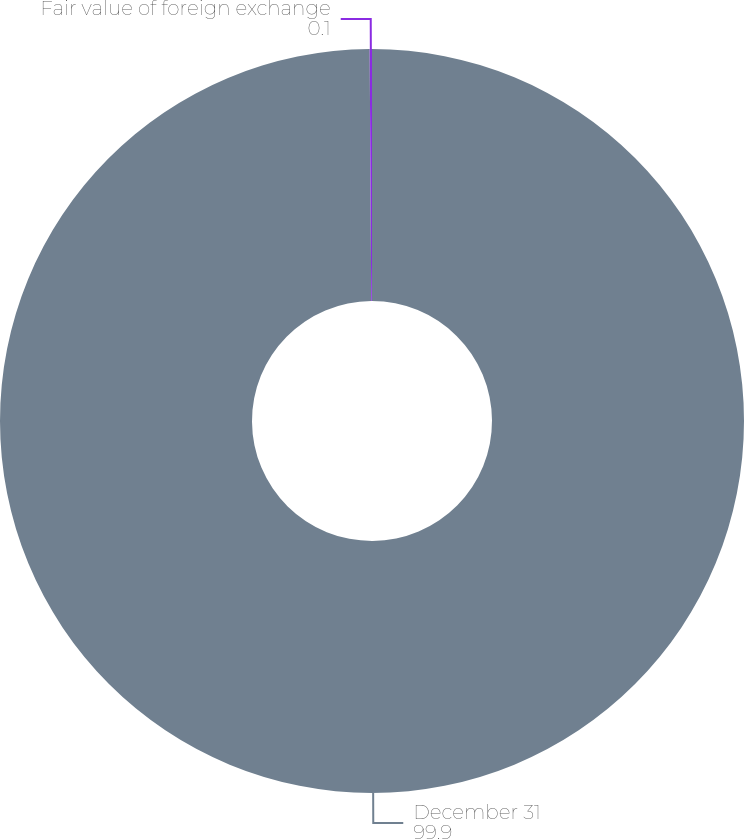<chart> <loc_0><loc_0><loc_500><loc_500><pie_chart><fcel>December 31<fcel>Fair value of foreign exchange<nl><fcel>99.9%<fcel>0.1%<nl></chart> 